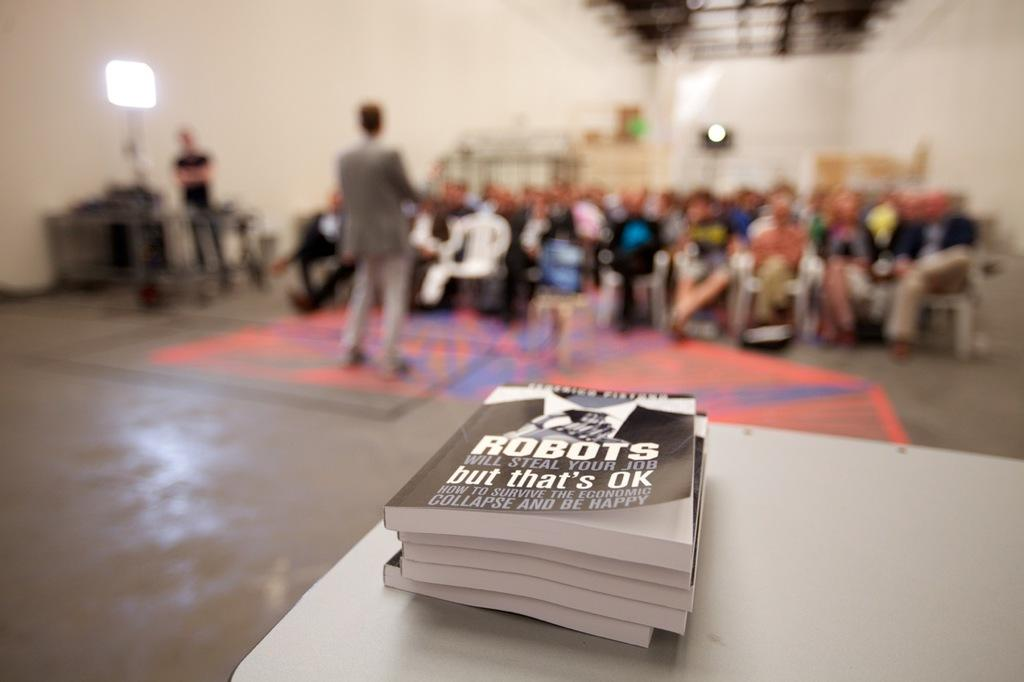<image>
Offer a succinct explanation of the picture presented. a book titled robots will steal your job but that's ok 